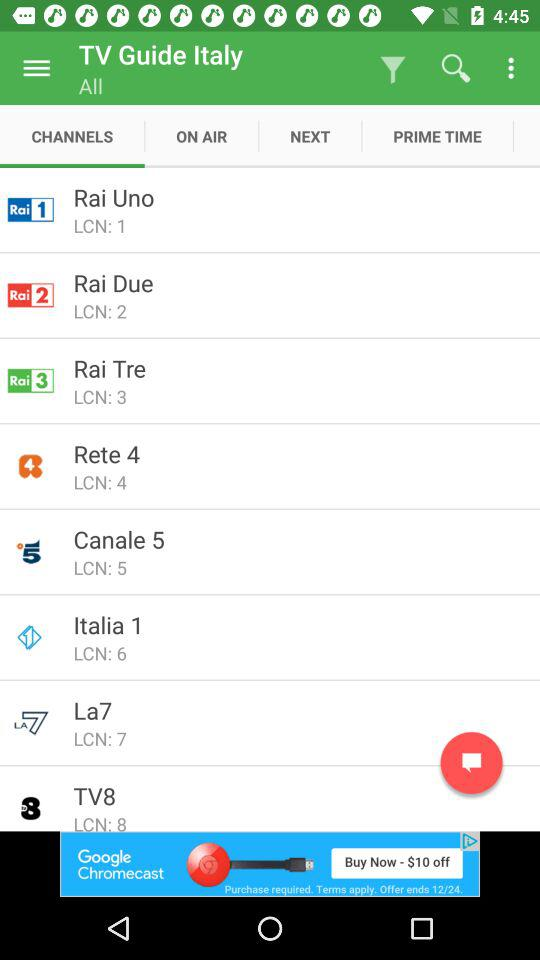How many channels are shown on the screen?
Answer the question using a single word or phrase. 8 